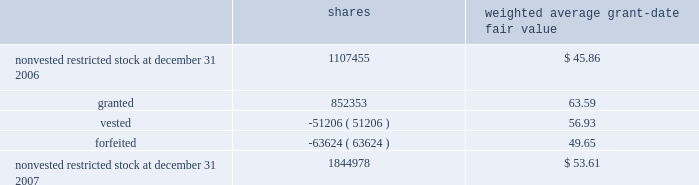Humana inc .
Notes to consolidated financial statements 2014 ( continued ) the total intrinsic value of stock options exercised during 2007 was $ 133.9 million , compared with $ 133.7 million during 2006 and $ 57.8 million during 2005 .
Cash received from stock option exercises for the years ended december 31 , 2007 , 2006 , and 2005 totaled $ 62.7 million , $ 49.2 million , and $ 36.4 million , respectively .
Total compensation expense related to nonvested options not yet recognized was $ 23.6 million at december 31 , 2007 .
We expect to recognize this compensation expense over a weighted average period of approximately 1.6 years .
Restricted stock awards restricted stock awards are granted with a fair value equal to the market price of our common stock on the date of grant .
Compensation expense is recorded straight-line over the vesting period , generally three years from the date of grant .
The weighted average grant date fair value of our restricted stock awards was $ 63.59 , $ 54.36 , and $ 32.81 for the years ended december 31 , 2007 , 2006 , and 2005 , respectively .
Activity for our restricted stock awards was as follows for the year ended december 31 , 2007 : shares weighted average grant-date fair value .
The fair value of shares vested during the years ended december 31 , 2007 , 2006 , and 2005 was $ 3.4 million , $ 2.3 million , and $ 0.6 million , respectively .
Total compensation expense related to nonvested restricted stock awards not yet recognized was $ 44.7 million at december 31 , 2007 .
We expect to recognize this compensation expense over a weighted average period of approximately 1.4 years .
There are no other contractual terms covering restricted stock awards once vested. .
What was the percent of the change in the weighted average grant date fair value of our restricted stock awards from 2006 to 2007? 
Rationale: the weighted average grant date fair value of our restricted stock awards increased by 16.97% from 2006 to 2007
Computations: ((63.59 - 54.36) / 54.36)
Answer: 0.16979. 